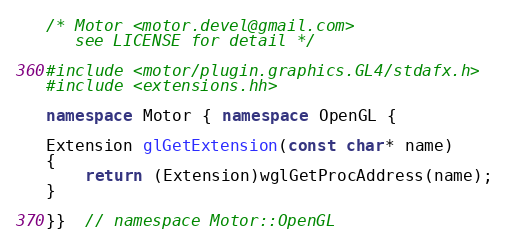<code> <loc_0><loc_0><loc_500><loc_500><_C++_>/* Motor <motor.devel@gmail.com>
   see LICENSE for detail */

#include <motor/plugin.graphics.GL4/stdafx.h>
#include <extensions.hh>

namespace Motor { namespace OpenGL {

Extension glGetExtension(const char* name)
{
    return (Extension)wglGetProcAddress(name);
}

}}  // namespace Motor::OpenGL
</code> 